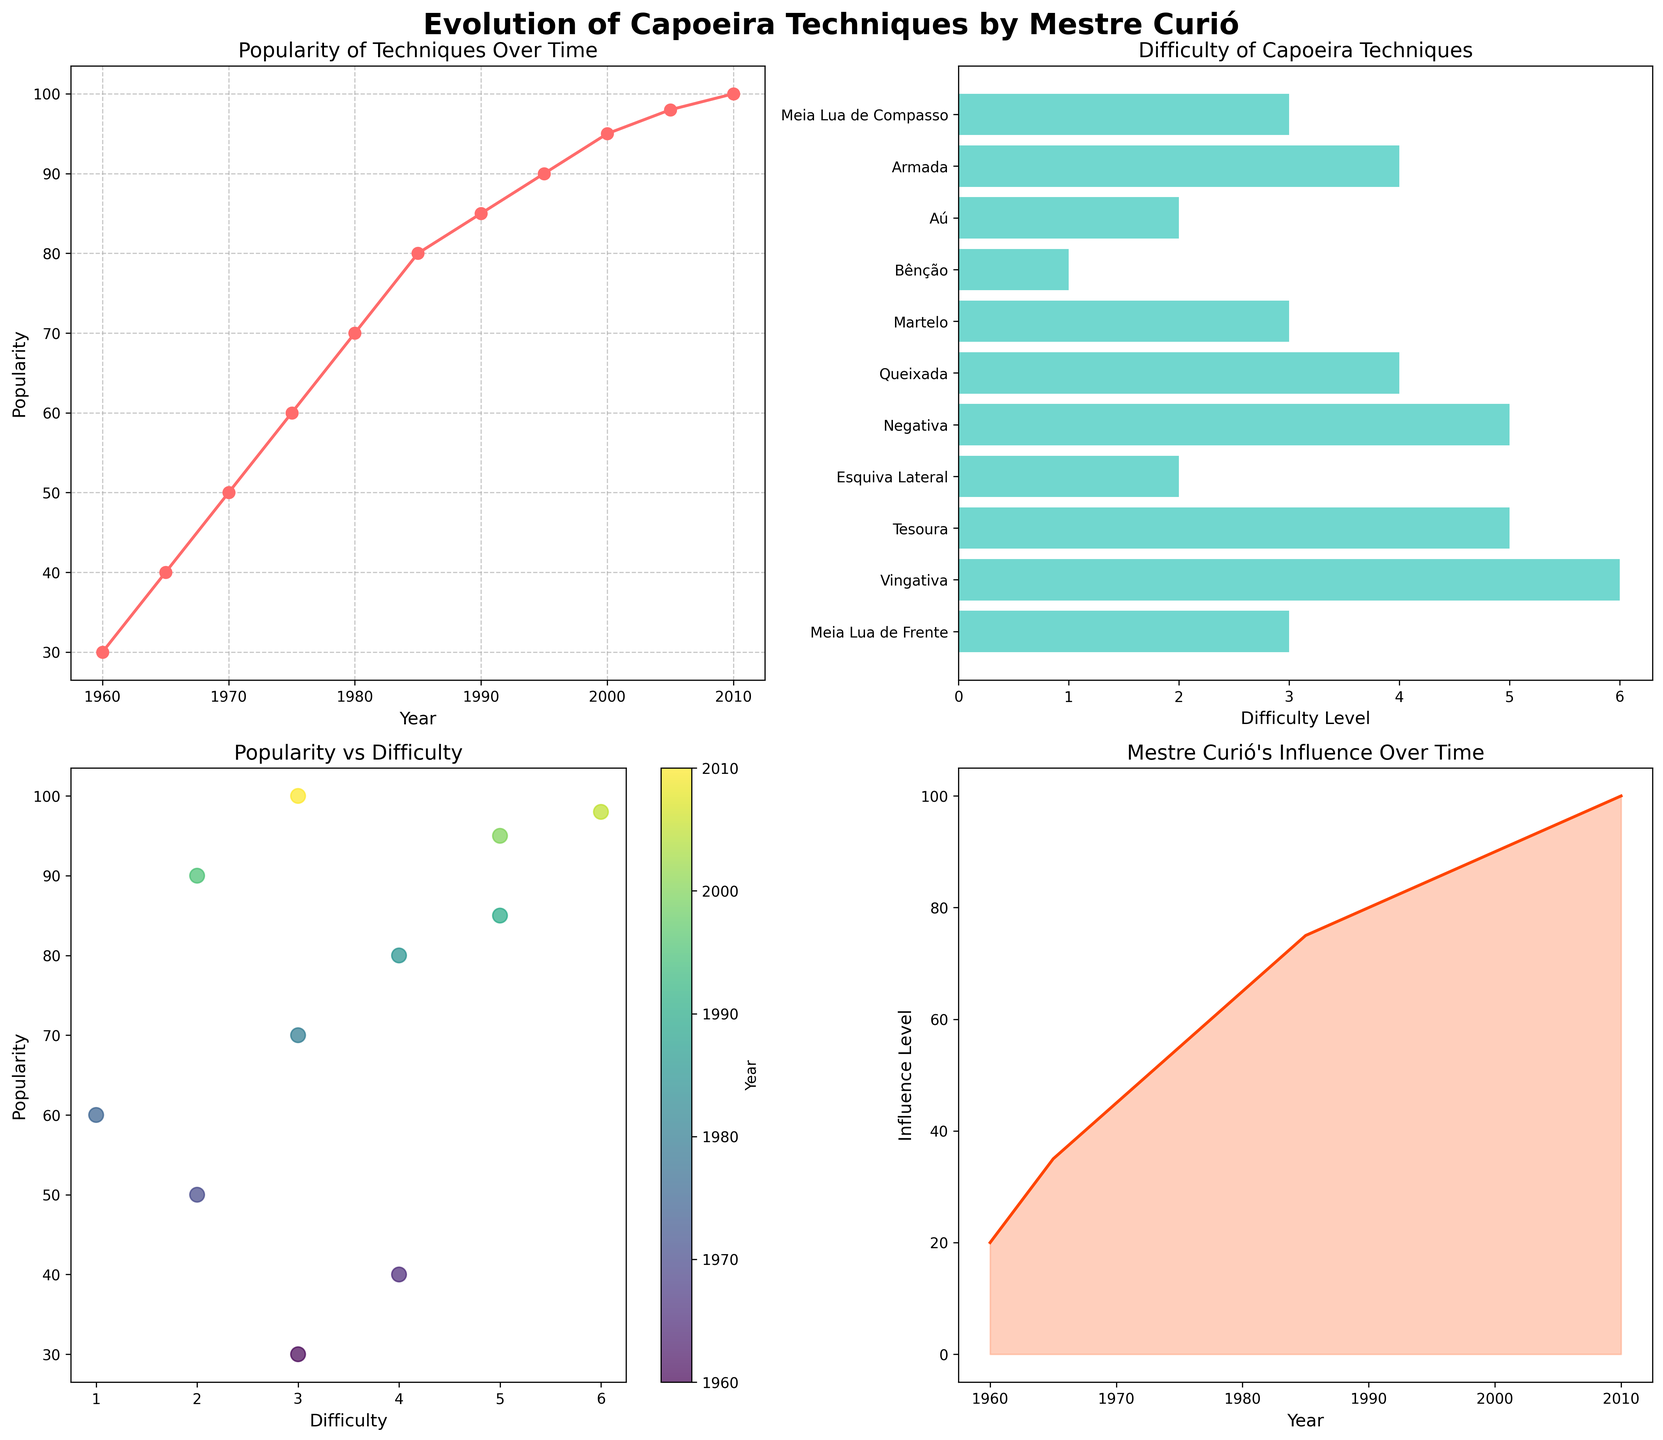Which year saw the highest popularity of Capoeira techniques? According to the line plot titled "Popularity of Techniques Over Time," the highest popularity, reaching 100, is observed in 2010.
Answer: 2010 Which Capoeira technique is the most difficult according to the bar plot? Referring to the bar plot "Difficulty of Capoeira Techniques," the most difficult technique is "Vingativa" with a difficulty level of 6.
Answer: Vingativa How has Mestre Curió's influence evolved over the years? The area plot titled "Mestre Curió's Influence Over Time" shows a consistent increase in influence, starting from 20 in 1960 to 100 in 2010.
Answer: Consistently increased What is the relationship between the difficulty and popularity of Capoeira techniques? The scatter plot "Popularity vs Difficulty" shows various difficulty levels with corresponding popularity, but no clear linear relationship. Higher difficulty generally correlates with higher popularity, but there are exceptions.
Answer: Higher difficulty often correlates with higher popularity Which year marks the point when popularity and Mestre Curió’s influence both saw significant increases? By examining the line plot and the area plot, significant increases in both popularity and influence can be observed around 1980-1985.
Answer: 1980-1985 How does the popularity of Capoeira techniques in 1975 compare to 2000? According to the line plot, the popularity in 1975 is 60, whereas in 2000, it is 95. Thus, it increased by 35 points.
Answer: Increased by 35 Is there a technique that has high popularity but a low difficulty level? In the bar plot and scatter plot, "Bênção" is both highly popular (60) and has a low difficulty level (1).
Answer: Bênção What is the average difficulty level of the techniques listed? Summing the difficulty levels (3+4+2+1+3+4+5+2+5+6+3) gives 38. Dividing by the number of techniques (11) results in approximately 3.45.
Answer: 3.45 